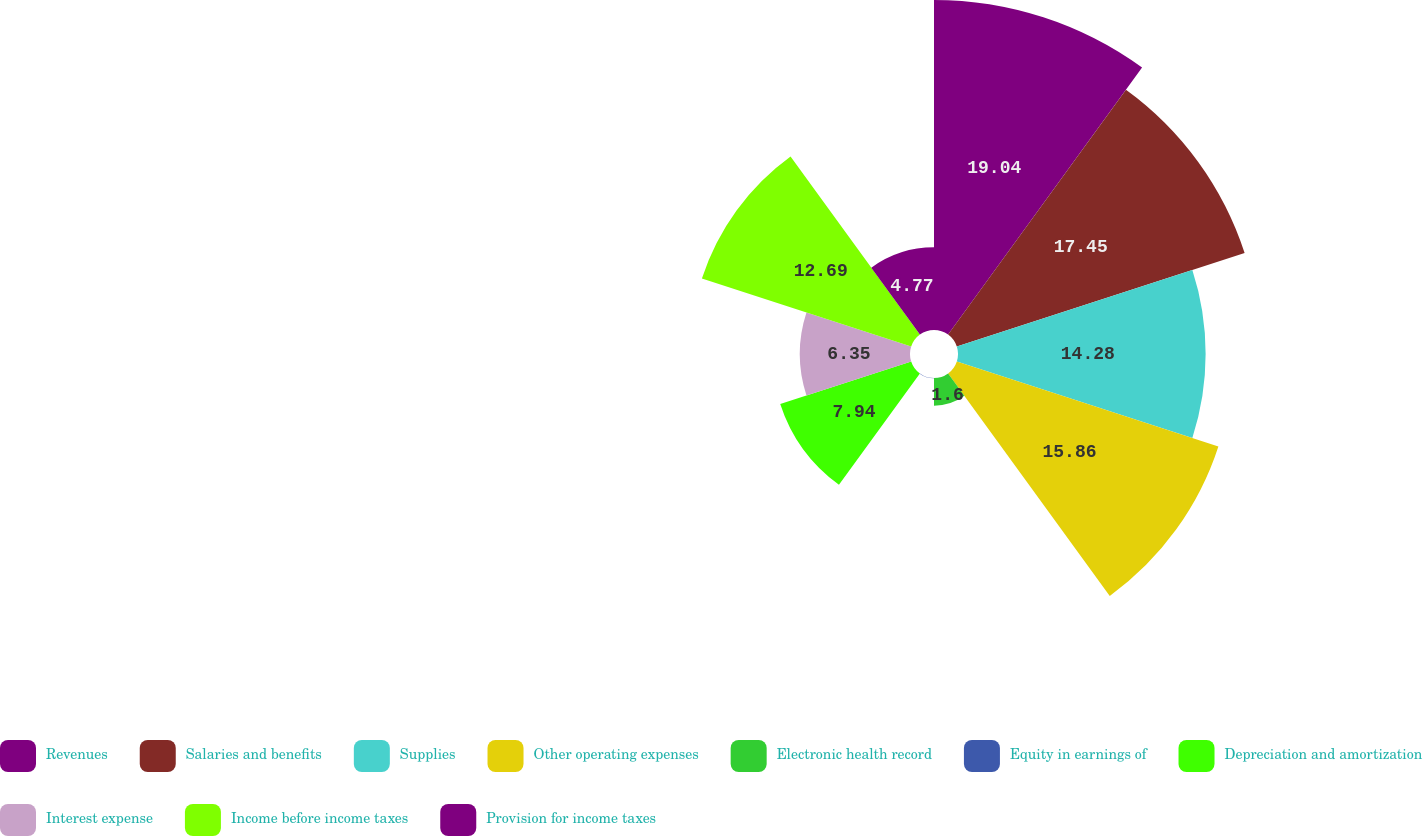Convert chart to OTSL. <chart><loc_0><loc_0><loc_500><loc_500><pie_chart><fcel>Revenues<fcel>Salaries and benefits<fcel>Supplies<fcel>Other operating expenses<fcel>Electronic health record<fcel>Equity in earnings of<fcel>Depreciation and amortization<fcel>Interest expense<fcel>Income before income taxes<fcel>Provision for income taxes<nl><fcel>19.03%<fcel>17.45%<fcel>14.28%<fcel>15.86%<fcel>1.6%<fcel>0.02%<fcel>7.94%<fcel>6.35%<fcel>12.69%<fcel>4.77%<nl></chart> 